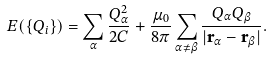Convert formula to latex. <formula><loc_0><loc_0><loc_500><loc_500>E ( \{ Q _ { i } \} ) = \sum _ { \alpha } \frac { Q _ { \alpha } ^ { 2 } } { 2 C } + \frac { \mu _ { 0 } } { 8 \pi } \sum _ { \alpha \neq \beta } \frac { Q _ { \alpha } Q _ { \beta } } { | \mathbf r _ { \alpha } - \mathbf r _ { \beta } | } .</formula> 